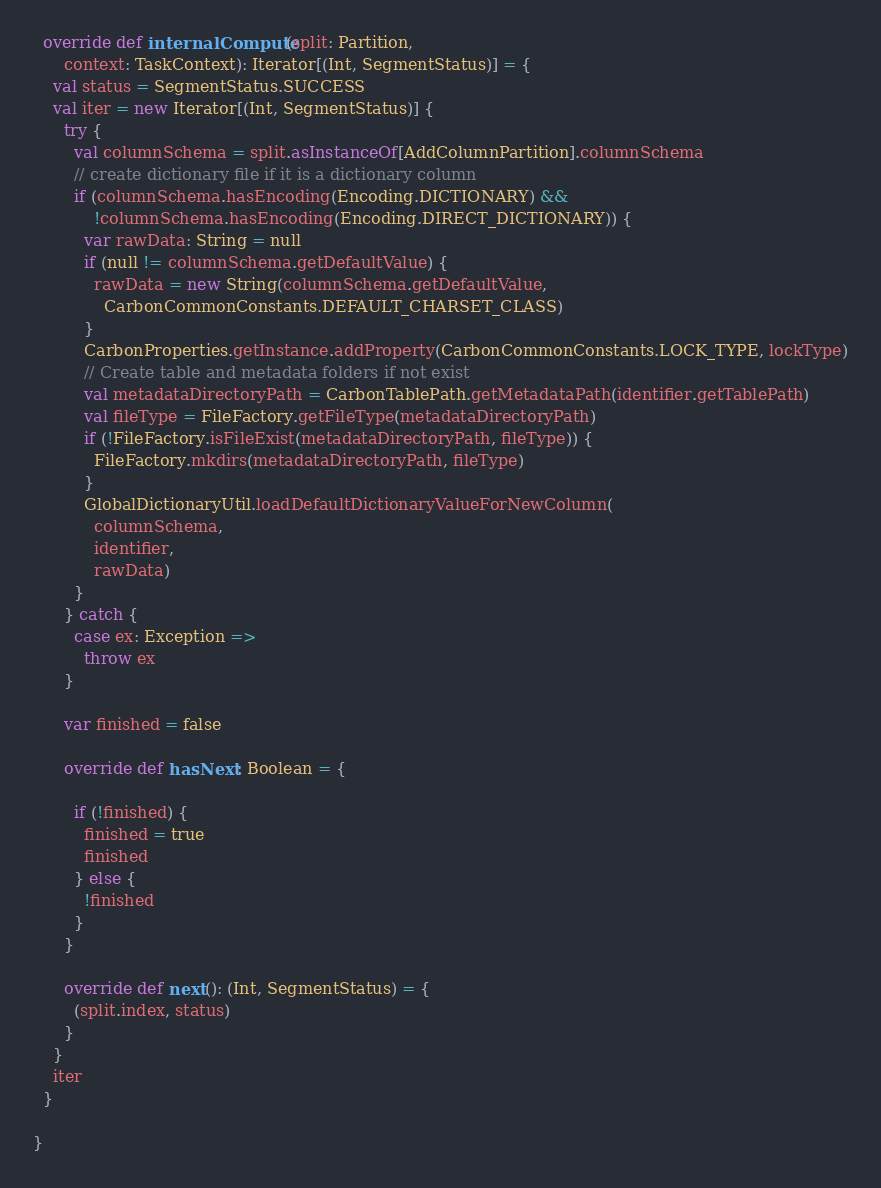<code> <loc_0><loc_0><loc_500><loc_500><_Scala_>  override def internalCompute(split: Partition,
      context: TaskContext): Iterator[(Int, SegmentStatus)] = {
    val status = SegmentStatus.SUCCESS
    val iter = new Iterator[(Int, SegmentStatus)] {
      try {
        val columnSchema = split.asInstanceOf[AddColumnPartition].columnSchema
        // create dictionary file if it is a dictionary column
        if (columnSchema.hasEncoding(Encoding.DICTIONARY) &&
            !columnSchema.hasEncoding(Encoding.DIRECT_DICTIONARY)) {
          var rawData: String = null
          if (null != columnSchema.getDefaultValue) {
            rawData = new String(columnSchema.getDefaultValue,
              CarbonCommonConstants.DEFAULT_CHARSET_CLASS)
          }
          CarbonProperties.getInstance.addProperty(CarbonCommonConstants.LOCK_TYPE, lockType)
          // Create table and metadata folders if not exist
          val metadataDirectoryPath = CarbonTablePath.getMetadataPath(identifier.getTablePath)
          val fileType = FileFactory.getFileType(metadataDirectoryPath)
          if (!FileFactory.isFileExist(metadataDirectoryPath, fileType)) {
            FileFactory.mkdirs(metadataDirectoryPath, fileType)
          }
          GlobalDictionaryUtil.loadDefaultDictionaryValueForNewColumn(
            columnSchema,
            identifier,
            rawData)
        }
      } catch {
        case ex: Exception =>
          throw ex
      }

      var finished = false

      override def hasNext: Boolean = {

        if (!finished) {
          finished = true
          finished
        } else {
          !finished
        }
      }

      override def next(): (Int, SegmentStatus) = {
        (split.index, status)
      }
    }
    iter
  }

}
</code> 